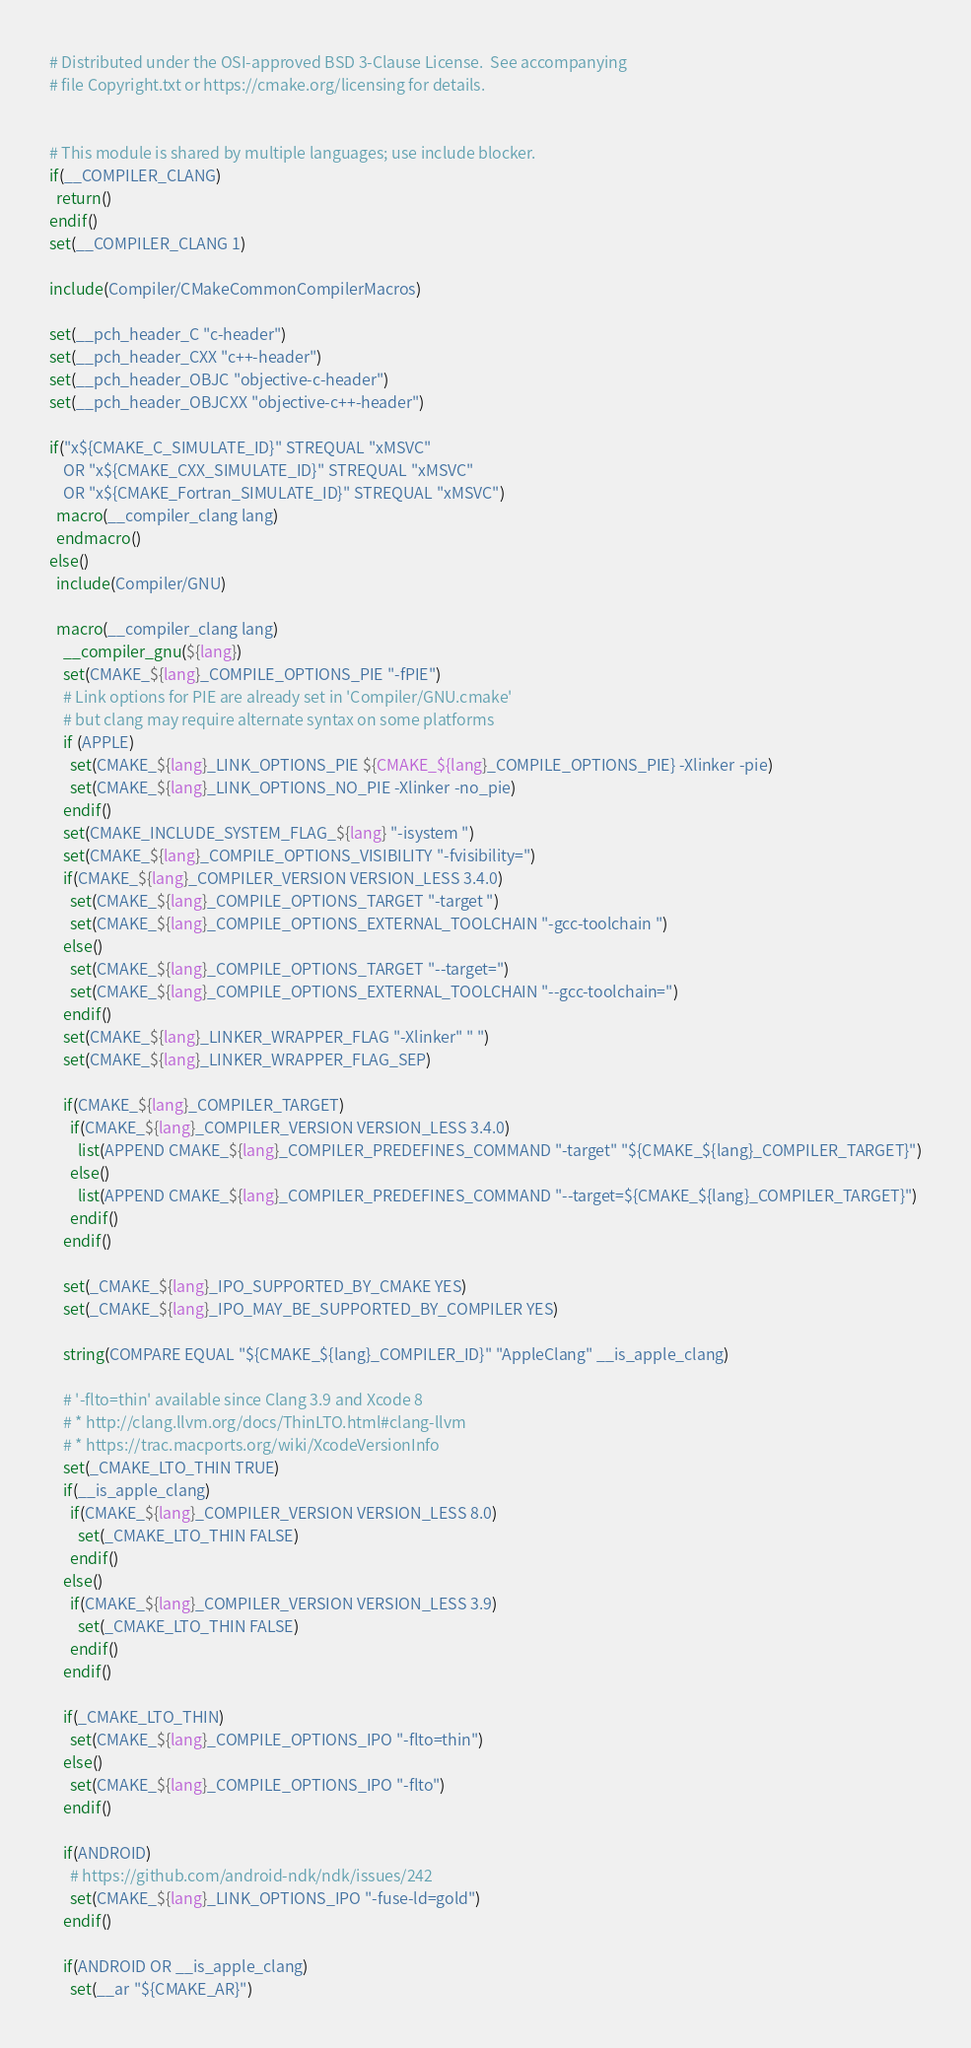Convert code to text. <code><loc_0><loc_0><loc_500><loc_500><_CMake_># Distributed under the OSI-approved BSD 3-Clause License.  See accompanying
# file Copyright.txt or https://cmake.org/licensing for details.


# This module is shared by multiple languages; use include blocker.
if(__COMPILER_CLANG)
  return()
endif()
set(__COMPILER_CLANG 1)

include(Compiler/CMakeCommonCompilerMacros)

set(__pch_header_C "c-header")
set(__pch_header_CXX "c++-header")
set(__pch_header_OBJC "objective-c-header")
set(__pch_header_OBJCXX "objective-c++-header")

if("x${CMAKE_C_SIMULATE_ID}" STREQUAL "xMSVC"
    OR "x${CMAKE_CXX_SIMULATE_ID}" STREQUAL "xMSVC"
    OR "x${CMAKE_Fortran_SIMULATE_ID}" STREQUAL "xMSVC")
  macro(__compiler_clang lang)
  endmacro()
else()
  include(Compiler/GNU)

  macro(__compiler_clang lang)
    __compiler_gnu(${lang})
    set(CMAKE_${lang}_COMPILE_OPTIONS_PIE "-fPIE")
    # Link options for PIE are already set in 'Compiler/GNU.cmake'
    # but clang may require alternate syntax on some platforms
    if (APPLE)
      set(CMAKE_${lang}_LINK_OPTIONS_PIE ${CMAKE_${lang}_COMPILE_OPTIONS_PIE} -Xlinker -pie)
      set(CMAKE_${lang}_LINK_OPTIONS_NO_PIE -Xlinker -no_pie)
    endif()
    set(CMAKE_INCLUDE_SYSTEM_FLAG_${lang} "-isystem ")
    set(CMAKE_${lang}_COMPILE_OPTIONS_VISIBILITY "-fvisibility=")
    if(CMAKE_${lang}_COMPILER_VERSION VERSION_LESS 3.4.0)
      set(CMAKE_${lang}_COMPILE_OPTIONS_TARGET "-target ")
      set(CMAKE_${lang}_COMPILE_OPTIONS_EXTERNAL_TOOLCHAIN "-gcc-toolchain ")
    else()
      set(CMAKE_${lang}_COMPILE_OPTIONS_TARGET "--target=")
      set(CMAKE_${lang}_COMPILE_OPTIONS_EXTERNAL_TOOLCHAIN "--gcc-toolchain=")
    endif()
    set(CMAKE_${lang}_LINKER_WRAPPER_FLAG "-Xlinker" " ")
    set(CMAKE_${lang}_LINKER_WRAPPER_FLAG_SEP)

    if(CMAKE_${lang}_COMPILER_TARGET)
      if(CMAKE_${lang}_COMPILER_VERSION VERSION_LESS 3.4.0)
        list(APPEND CMAKE_${lang}_COMPILER_PREDEFINES_COMMAND "-target" "${CMAKE_${lang}_COMPILER_TARGET}")
      else()
        list(APPEND CMAKE_${lang}_COMPILER_PREDEFINES_COMMAND "--target=${CMAKE_${lang}_COMPILER_TARGET}")
      endif()
    endif()

    set(_CMAKE_${lang}_IPO_SUPPORTED_BY_CMAKE YES)
    set(_CMAKE_${lang}_IPO_MAY_BE_SUPPORTED_BY_COMPILER YES)

    string(COMPARE EQUAL "${CMAKE_${lang}_COMPILER_ID}" "AppleClang" __is_apple_clang)

    # '-flto=thin' available since Clang 3.9 and Xcode 8
    # * http://clang.llvm.org/docs/ThinLTO.html#clang-llvm
    # * https://trac.macports.org/wiki/XcodeVersionInfo
    set(_CMAKE_LTO_THIN TRUE)
    if(__is_apple_clang)
      if(CMAKE_${lang}_COMPILER_VERSION VERSION_LESS 8.0)
        set(_CMAKE_LTO_THIN FALSE)
      endif()
    else()
      if(CMAKE_${lang}_COMPILER_VERSION VERSION_LESS 3.9)
        set(_CMAKE_LTO_THIN FALSE)
      endif()
    endif()

    if(_CMAKE_LTO_THIN)
      set(CMAKE_${lang}_COMPILE_OPTIONS_IPO "-flto=thin")
    else()
      set(CMAKE_${lang}_COMPILE_OPTIONS_IPO "-flto")
    endif()

    if(ANDROID)
      # https://github.com/android-ndk/ndk/issues/242
      set(CMAKE_${lang}_LINK_OPTIONS_IPO "-fuse-ld=gold")
    endif()

    if(ANDROID OR __is_apple_clang)
      set(__ar "${CMAKE_AR}")</code> 